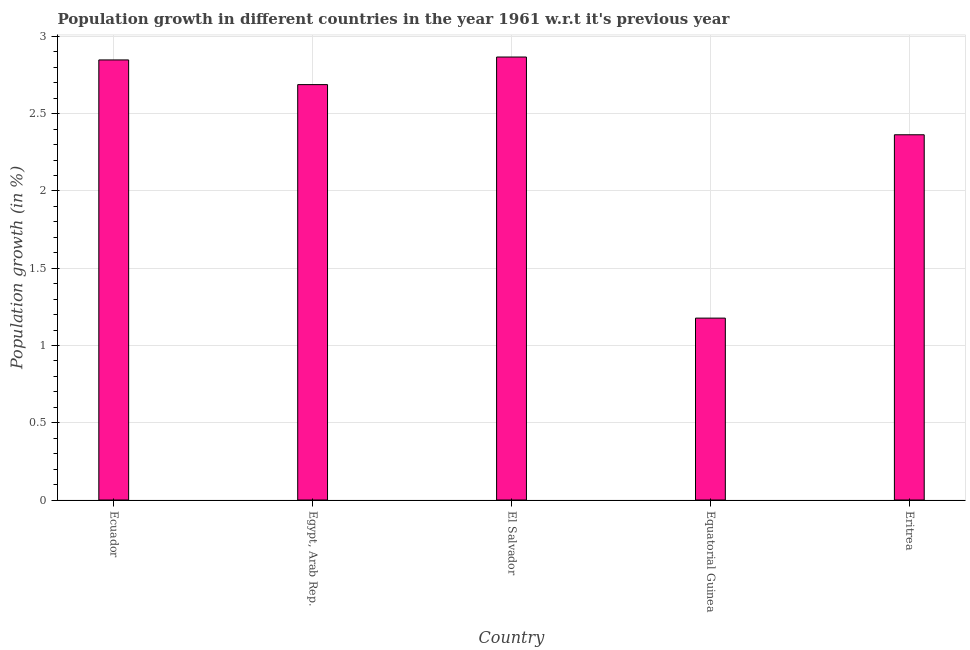Does the graph contain any zero values?
Provide a succinct answer. No. Does the graph contain grids?
Your answer should be very brief. Yes. What is the title of the graph?
Your answer should be compact. Population growth in different countries in the year 1961 w.r.t it's previous year. What is the label or title of the Y-axis?
Offer a very short reply. Population growth (in %). What is the population growth in Ecuador?
Provide a succinct answer. 2.85. Across all countries, what is the maximum population growth?
Keep it short and to the point. 2.87. Across all countries, what is the minimum population growth?
Make the answer very short. 1.18. In which country was the population growth maximum?
Keep it short and to the point. El Salvador. In which country was the population growth minimum?
Your response must be concise. Equatorial Guinea. What is the sum of the population growth?
Keep it short and to the point. 11.94. What is the difference between the population growth in Egypt, Arab Rep. and Equatorial Guinea?
Provide a succinct answer. 1.51. What is the average population growth per country?
Offer a very short reply. 2.39. What is the median population growth?
Keep it short and to the point. 2.69. What is the ratio of the population growth in Egypt, Arab Rep. to that in El Salvador?
Keep it short and to the point. 0.94. Is the population growth in Egypt, Arab Rep. less than that in El Salvador?
Your response must be concise. Yes. What is the difference between the highest and the second highest population growth?
Your response must be concise. 0.02. Is the sum of the population growth in Egypt, Arab Rep. and Eritrea greater than the maximum population growth across all countries?
Your answer should be very brief. Yes. What is the difference between the highest and the lowest population growth?
Provide a succinct answer. 1.69. How many countries are there in the graph?
Offer a terse response. 5. What is the difference between two consecutive major ticks on the Y-axis?
Keep it short and to the point. 0.5. What is the Population growth (in %) in Ecuador?
Offer a terse response. 2.85. What is the Population growth (in %) in Egypt, Arab Rep.?
Your answer should be compact. 2.69. What is the Population growth (in %) in El Salvador?
Provide a succinct answer. 2.87. What is the Population growth (in %) in Equatorial Guinea?
Offer a very short reply. 1.18. What is the Population growth (in %) of Eritrea?
Provide a succinct answer. 2.36. What is the difference between the Population growth (in %) in Ecuador and Egypt, Arab Rep.?
Your response must be concise. 0.16. What is the difference between the Population growth (in %) in Ecuador and El Salvador?
Offer a very short reply. -0.02. What is the difference between the Population growth (in %) in Ecuador and Equatorial Guinea?
Make the answer very short. 1.67. What is the difference between the Population growth (in %) in Ecuador and Eritrea?
Give a very brief answer. 0.48. What is the difference between the Population growth (in %) in Egypt, Arab Rep. and El Salvador?
Offer a terse response. -0.18. What is the difference between the Population growth (in %) in Egypt, Arab Rep. and Equatorial Guinea?
Provide a short and direct response. 1.51. What is the difference between the Population growth (in %) in Egypt, Arab Rep. and Eritrea?
Provide a succinct answer. 0.32. What is the difference between the Population growth (in %) in El Salvador and Equatorial Guinea?
Your answer should be very brief. 1.69. What is the difference between the Population growth (in %) in El Salvador and Eritrea?
Your answer should be compact. 0.5. What is the difference between the Population growth (in %) in Equatorial Guinea and Eritrea?
Provide a succinct answer. -1.19. What is the ratio of the Population growth (in %) in Ecuador to that in Egypt, Arab Rep.?
Keep it short and to the point. 1.06. What is the ratio of the Population growth (in %) in Ecuador to that in El Salvador?
Offer a terse response. 0.99. What is the ratio of the Population growth (in %) in Ecuador to that in Equatorial Guinea?
Offer a terse response. 2.42. What is the ratio of the Population growth (in %) in Ecuador to that in Eritrea?
Make the answer very short. 1.21. What is the ratio of the Population growth (in %) in Egypt, Arab Rep. to that in El Salvador?
Your answer should be compact. 0.94. What is the ratio of the Population growth (in %) in Egypt, Arab Rep. to that in Equatorial Guinea?
Your answer should be compact. 2.28. What is the ratio of the Population growth (in %) in Egypt, Arab Rep. to that in Eritrea?
Give a very brief answer. 1.14. What is the ratio of the Population growth (in %) in El Salvador to that in Equatorial Guinea?
Keep it short and to the point. 2.44. What is the ratio of the Population growth (in %) in El Salvador to that in Eritrea?
Offer a very short reply. 1.21. What is the ratio of the Population growth (in %) in Equatorial Guinea to that in Eritrea?
Your response must be concise. 0.5. 